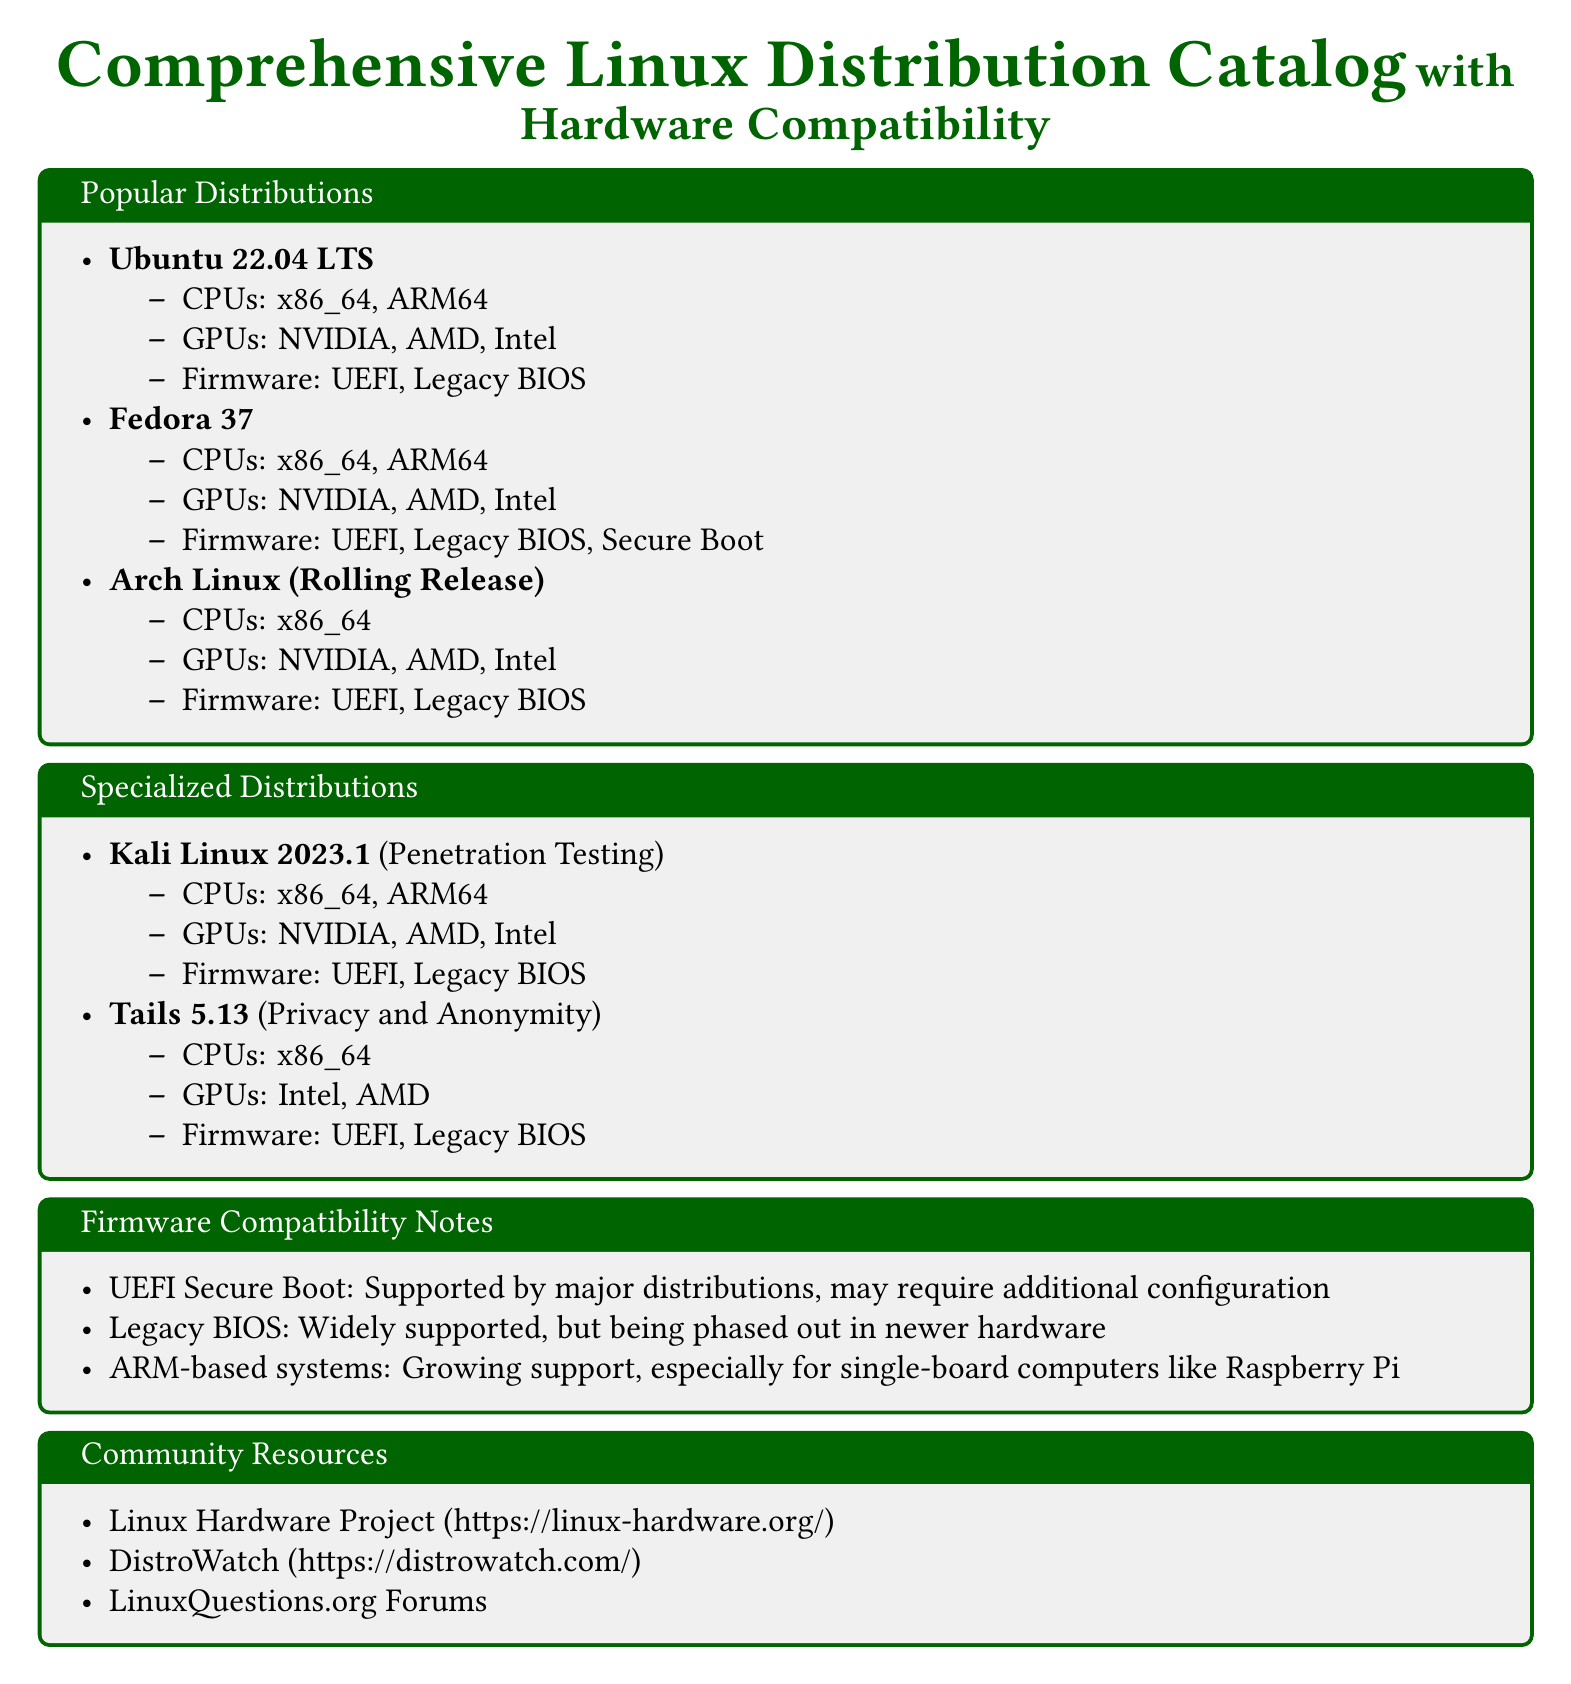What is the latest version of Ubuntu featured? The document lists the version of Ubuntu as 22.04 LTS.
Answer: 22.04 LTS Which distribution is tailored for penetration testing? The document specifically mentions Kali Linux as the distribution for penetration testing.
Answer: Kali Linux What firmware is supported by Fedora 37? The document states that Fedora 37 supports UEFI, Legacy BIOS, and Secure Boot firmware.
Answer: UEFI, Legacy BIOS, Secure Boot How many CPU architectures are mentioned for Arch Linux? The document indicates that Arch Linux supports one CPU architecture, which is x86_64.
Answer: 1 Which distribution is noted for privacy and anonymity? The document identifies Tails as the distribution focused on privacy and anonymity.
Answer: Tails What type of support is growing for ARM-based systems? The document mentions a growing support for ARM-based systems, particularly for single-board computers.
Answer: Support for single-board computers Is Secure Boot supported by most distributions? The document indicates that UEFI Secure Boot is supported by major distributions with possible configuration requirements.
Answer: Yes How many GPUs are listed for support across the popular distributions? The document lists NVIDIA, AMD, and Intel as supported GPUs across the various distributions.
Answer: 3 